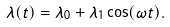<formula> <loc_0><loc_0><loc_500><loc_500>\lambda ( t ) = \lambda _ { 0 } + \lambda _ { 1 } \cos ( \omega t ) .</formula> 